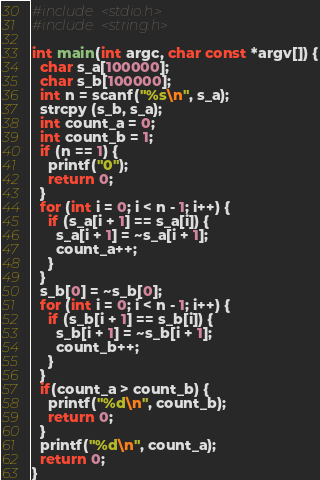<code> <loc_0><loc_0><loc_500><loc_500><_C_>#include <stdio.h>
#include <string.h>

int main(int argc, char const *argv[]) {
  char s_a[100000];
  char s_b[100000];
  int n = scanf("%s\n", s_a);
  strcpy (s_b, s_a);
  int count_a = 0;
  int count_b = 1;
  if (n == 1) {
    printf("0");
    return 0;
  }
  for (int i = 0; i < n - 1; i++) {
    if (s_a[i + 1] == s_a[i]) {
      s_a[i + 1] = ~s_a[i + 1];
      count_a++;
    }
  }
  s_b[0] = ~s_b[0];
  for (int i = 0; i < n - 1; i++) {
    if (s_b[i + 1] == s_b[i]) {
      s_b[i + 1] = ~s_b[i + 1];
      count_b++;
    }
  }
  if(count_a > count_b) {
    printf("%d\n", count_b);
    return 0;
  }
  printf("%d\n", count_a);
  return 0;
}
</code> 